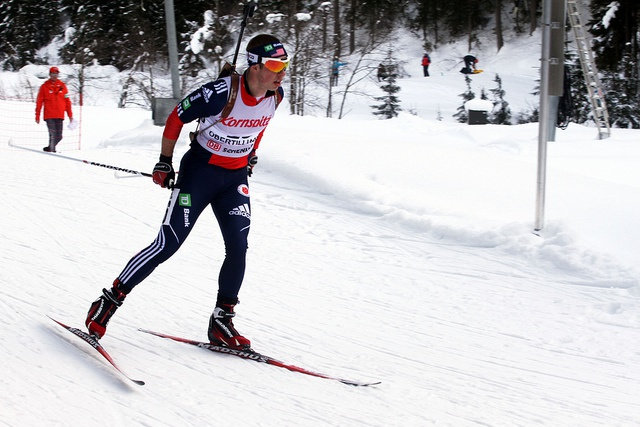Describe the objects in this image and their specific colors. I can see people in black, lavender, darkgray, and maroon tones, skis in black, lightgray, darkgray, and gray tones, people in black, red, brown, and white tones, people in black, brown, maroon, and gray tones, and people in black, gray, and darkgray tones in this image. 